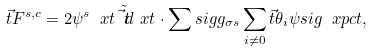Convert formula to latex. <formula><loc_0><loc_0><loc_500><loc_500>\vec { t } { F } ^ { s , c } = 2 \psi ^ { s } \ x t \tilde { \vec { t } { d } } \ x t \cdot \sum s i g g _ { \sigma s } \sum _ { i \neq 0 } \vec { t } { \theta } _ { i } \psi s i g \ x p c t ,</formula> 